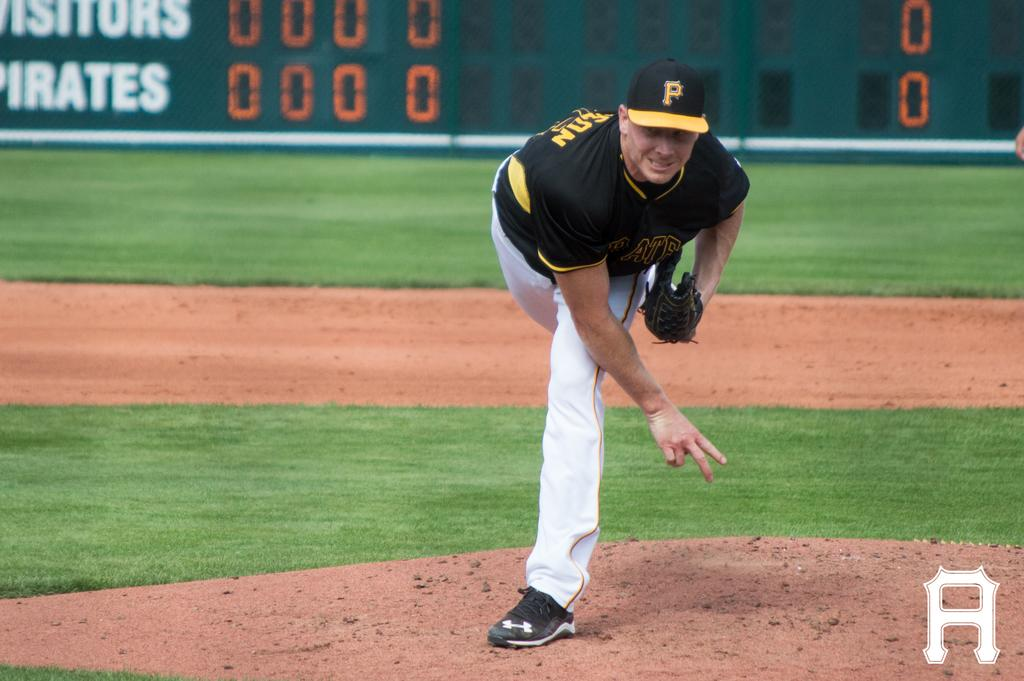<image>
Offer a succinct explanation of the picture presented. The pitcher for the Pirates just threw a ball from the mound. 